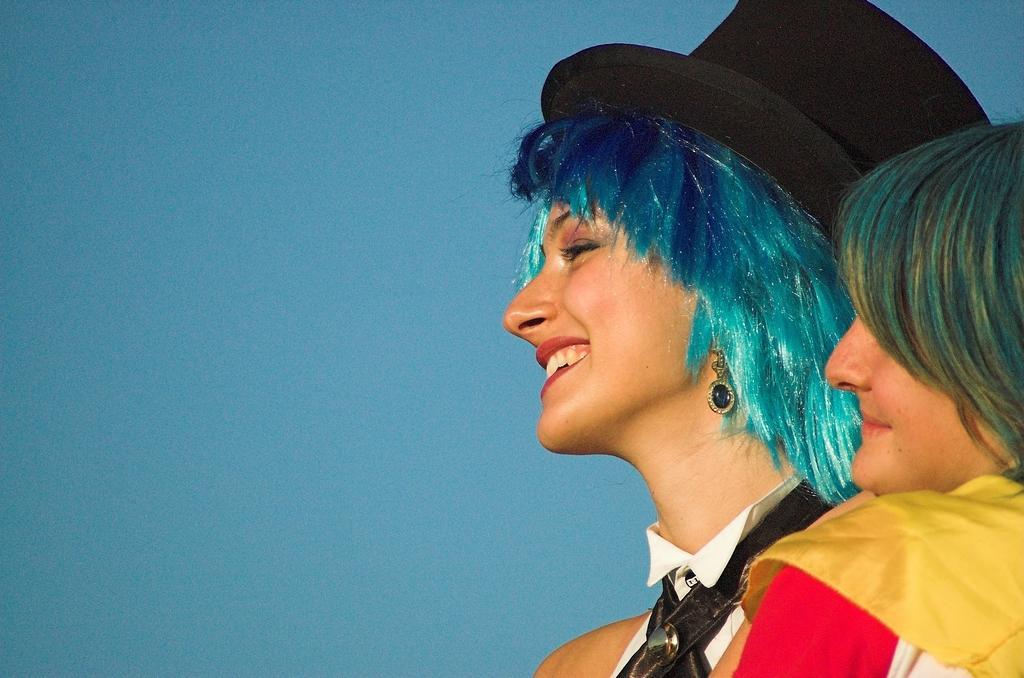In one or two sentences, can you explain what this image depicts? In this image there are persons smiling and there is a woman wearing a hat which is black in colour. 